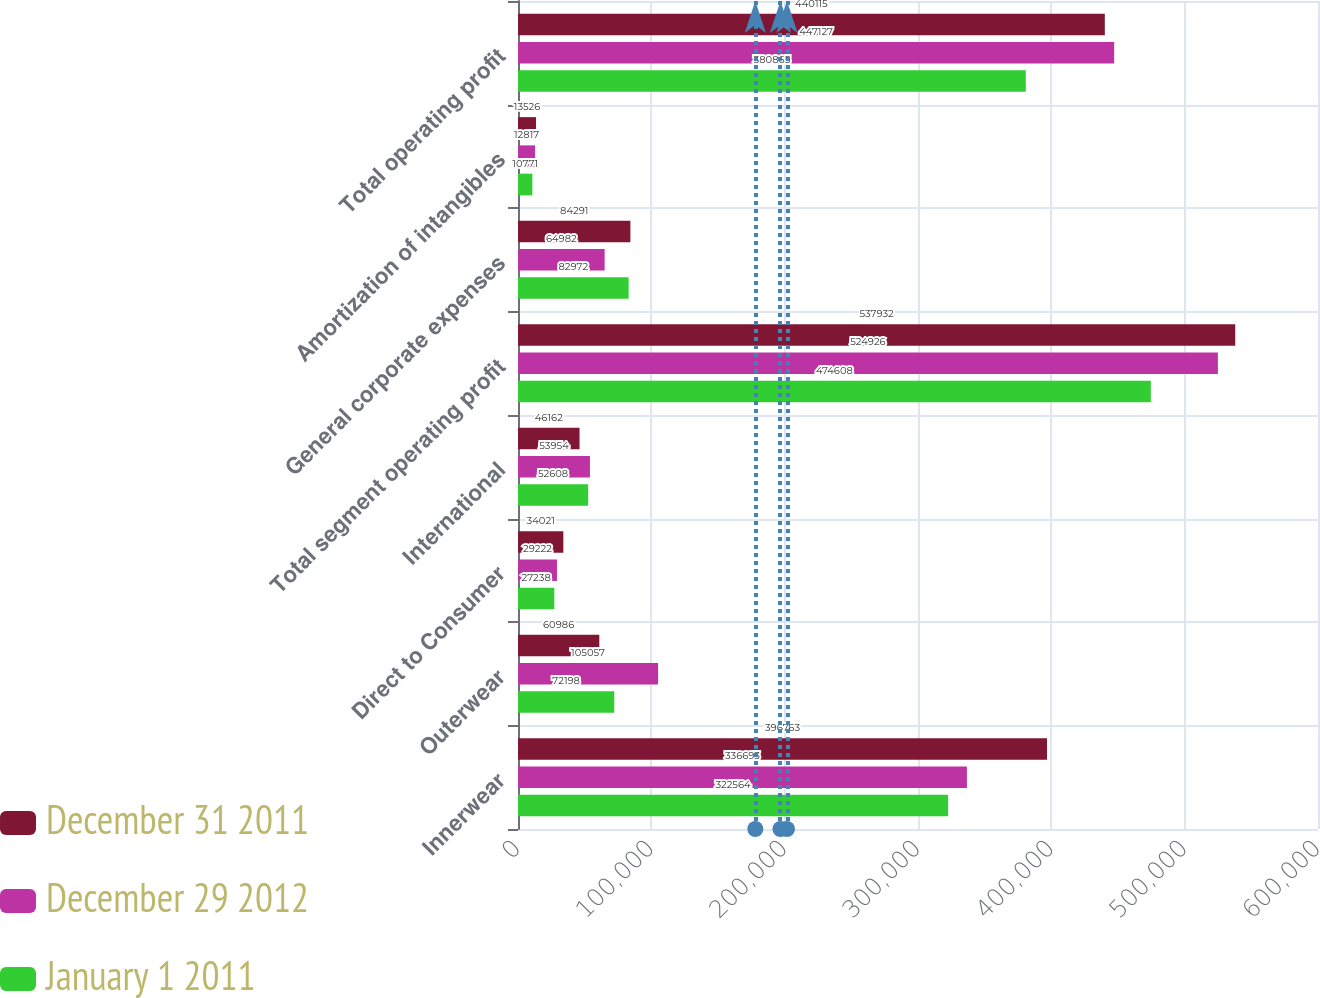Convert chart to OTSL. <chart><loc_0><loc_0><loc_500><loc_500><stacked_bar_chart><ecel><fcel>Innerwear<fcel>Outerwear<fcel>Direct to Consumer<fcel>International<fcel>Total segment operating profit<fcel>General corporate expenses<fcel>Amortization of intangibles<fcel>Total operating profit<nl><fcel>December 31 2011<fcel>396763<fcel>60986<fcel>34021<fcel>46162<fcel>537932<fcel>84291<fcel>13526<fcel>440115<nl><fcel>December 29 2012<fcel>336693<fcel>105057<fcel>29222<fcel>53954<fcel>524926<fcel>64982<fcel>12817<fcel>447127<nl><fcel>January 1 2011<fcel>322564<fcel>72198<fcel>27238<fcel>52608<fcel>474608<fcel>82972<fcel>10771<fcel>380865<nl></chart> 